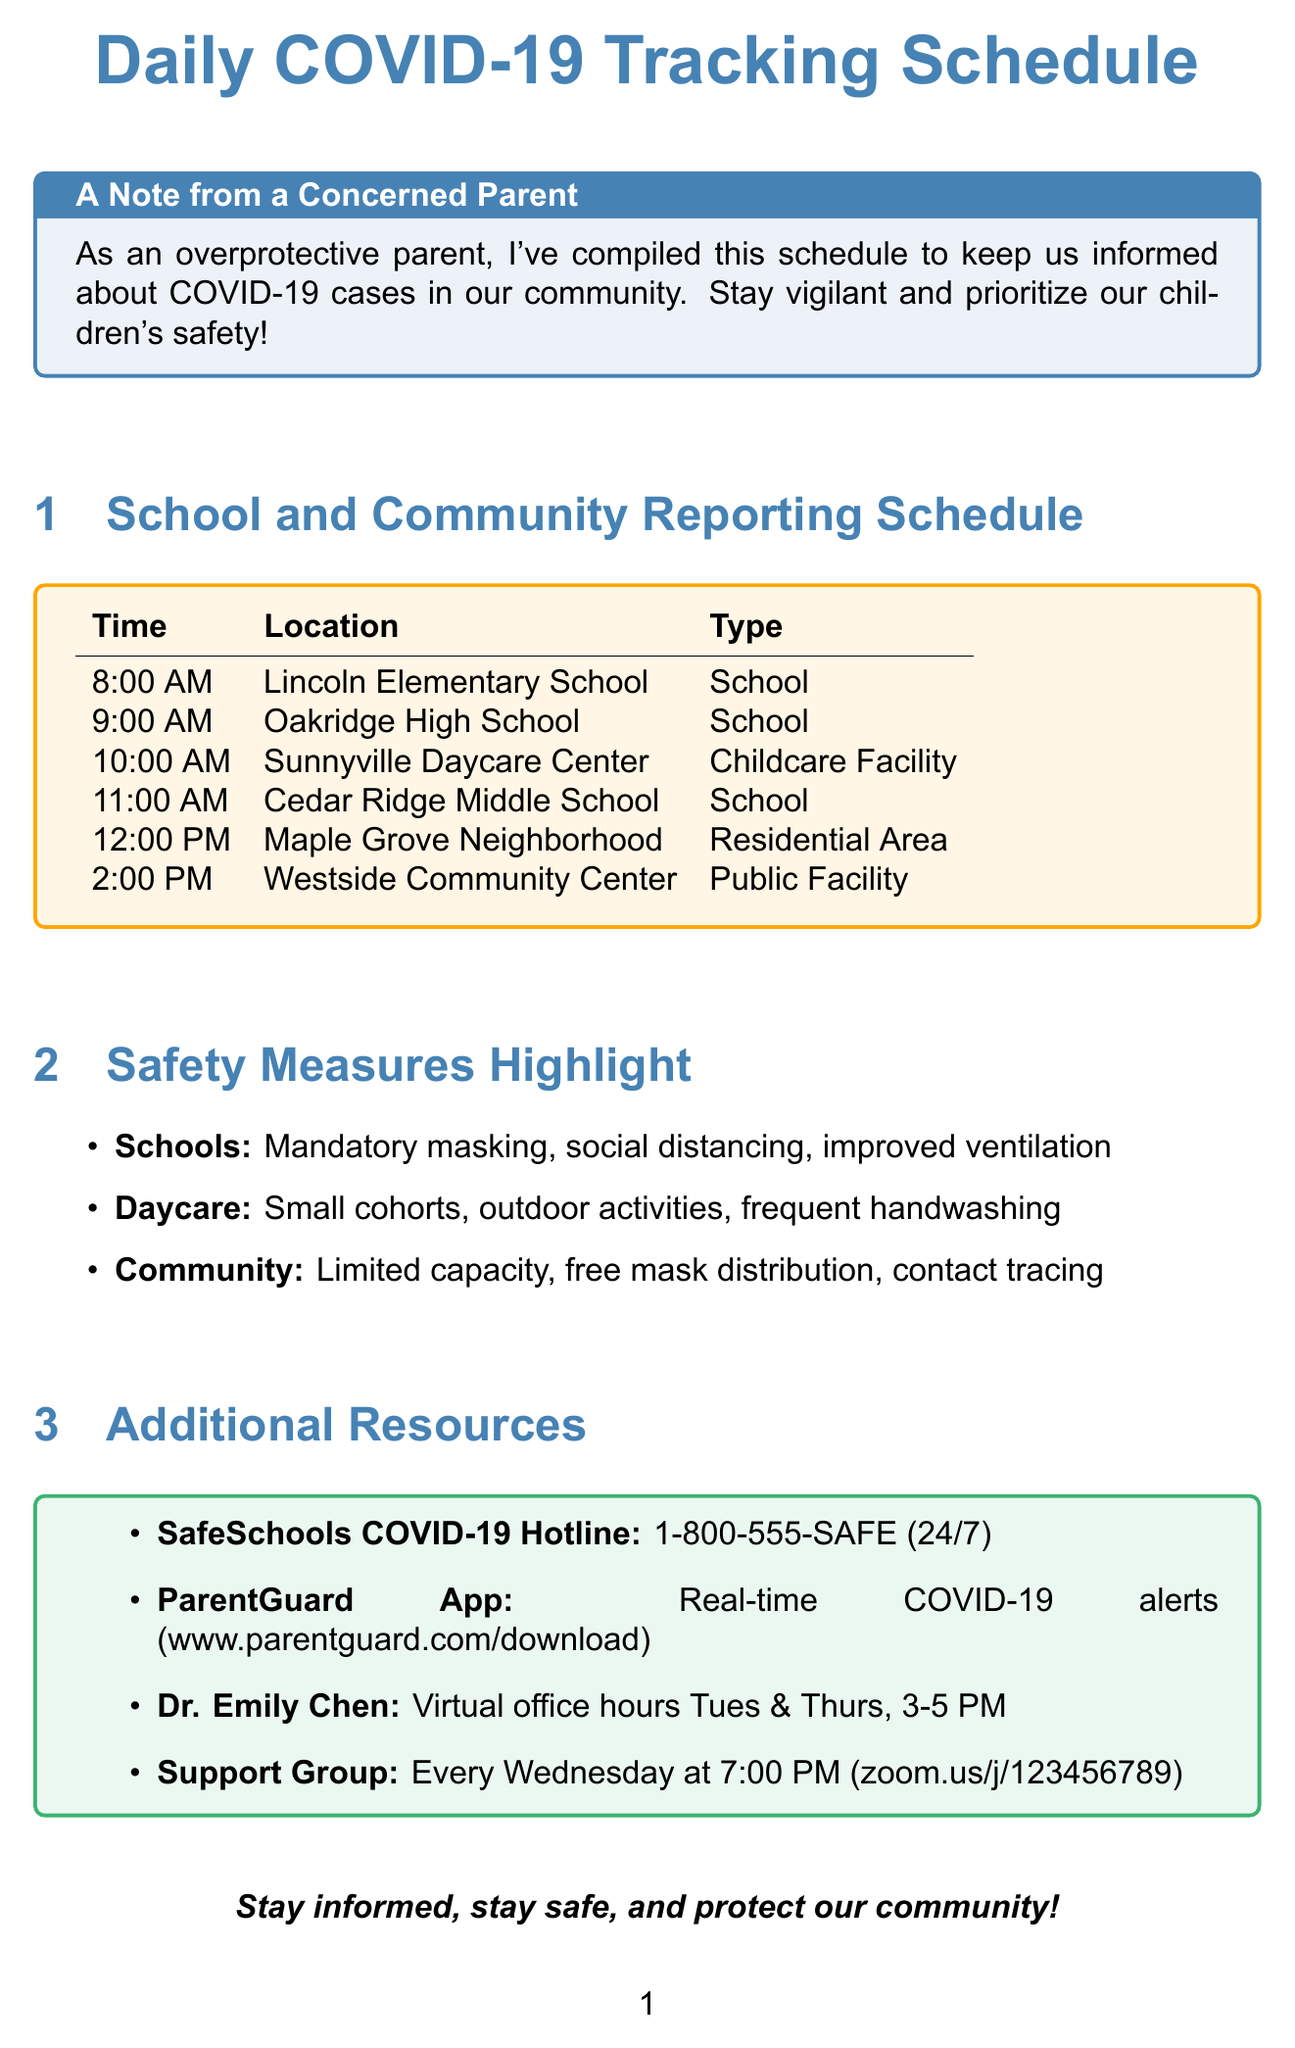what time does Cedar Ridge Middle School report cases? Cedar Ridge Middle School's case reporting time is mentioned in the document.
Answer: 11:00 AM what safety measure is used at Sunnyville Daycare Center? The document lists the safety measures specifically for Sunnyville Daycare Center.
Answer: Small cohorts which data source is used by Lincoln Elementary School? The document provides the data sources for Lincoln Elementary School's case tracking.
Answer: School nurse's office what type of location is Oakridge High School? The document categorizes Oakridge High School with its type.
Answer: School how often does the Community COVID-19 Support Group meet? The document specifies the meeting schedule for the Community COVID-19 Support Group.
Answer: Every Wednesday what is the phone number for the SafeSchools COVID-19 Hotline? The document provides contact information for the SafeSchools COVID-19 Hotline.
Answer: 1-800-555-SAFE which school has a hybrid learning model as a safety measure? The document states which school implements the hybrid learning model as part of safety measures.
Answer: Oakridge High School what time do COVID-19 cases get reported in the Maple Grove Neighborhood? The document indicates the specific case reporting time for the Maple Grove Neighborhood.
Answer: 12:00 PM what additional resource provides real-time COVID-19 alerts? The document names an additional resource that offers real-time COVID-19 alerts.
Answer: ParentGuard App 